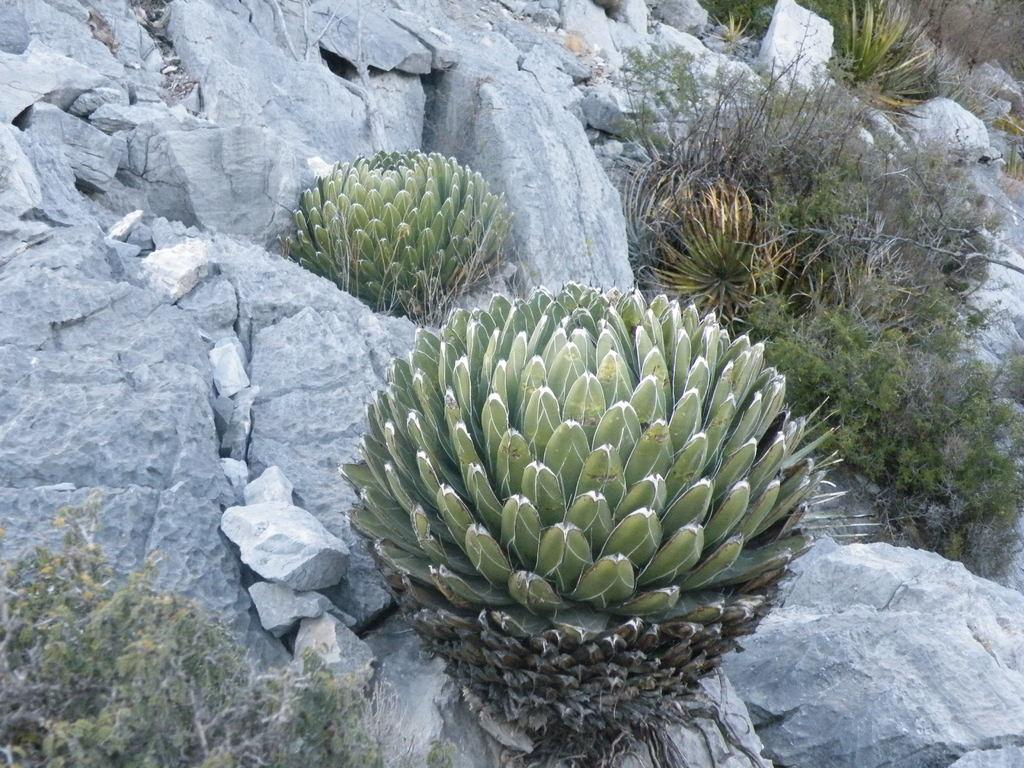Where was the image taken? The image was taken outside. What can be seen in the foreground of the image? There are plants and rocks in the foreground of the image. Are there any other objects in the foreground of the image besides plants and rocks? Yes, there are other objects in the foreground of the image. What type of quince is being used to clean the soap in the image? There is no quince or soap present in the image; it features plants, rocks, and other objects in the foreground. Can you tell me where the office is located in the image? There is no office present in the image; it was taken outside and features plants, rocks, and other objects in the foreground. 